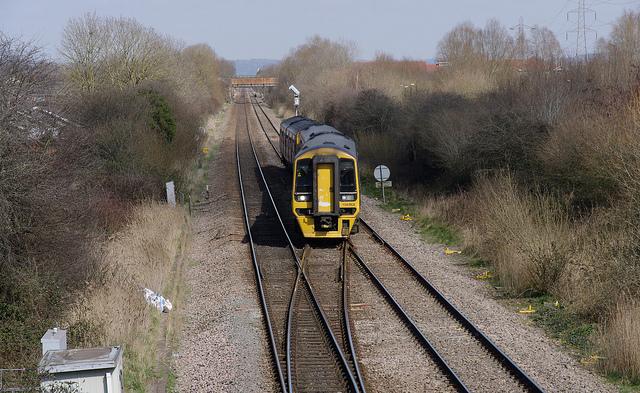What color is the sky?
Quick response, please. Blue. How many tracks can you spot?
Quick response, please. 3. What color is the front of the train?
Short answer required. Yellow. 